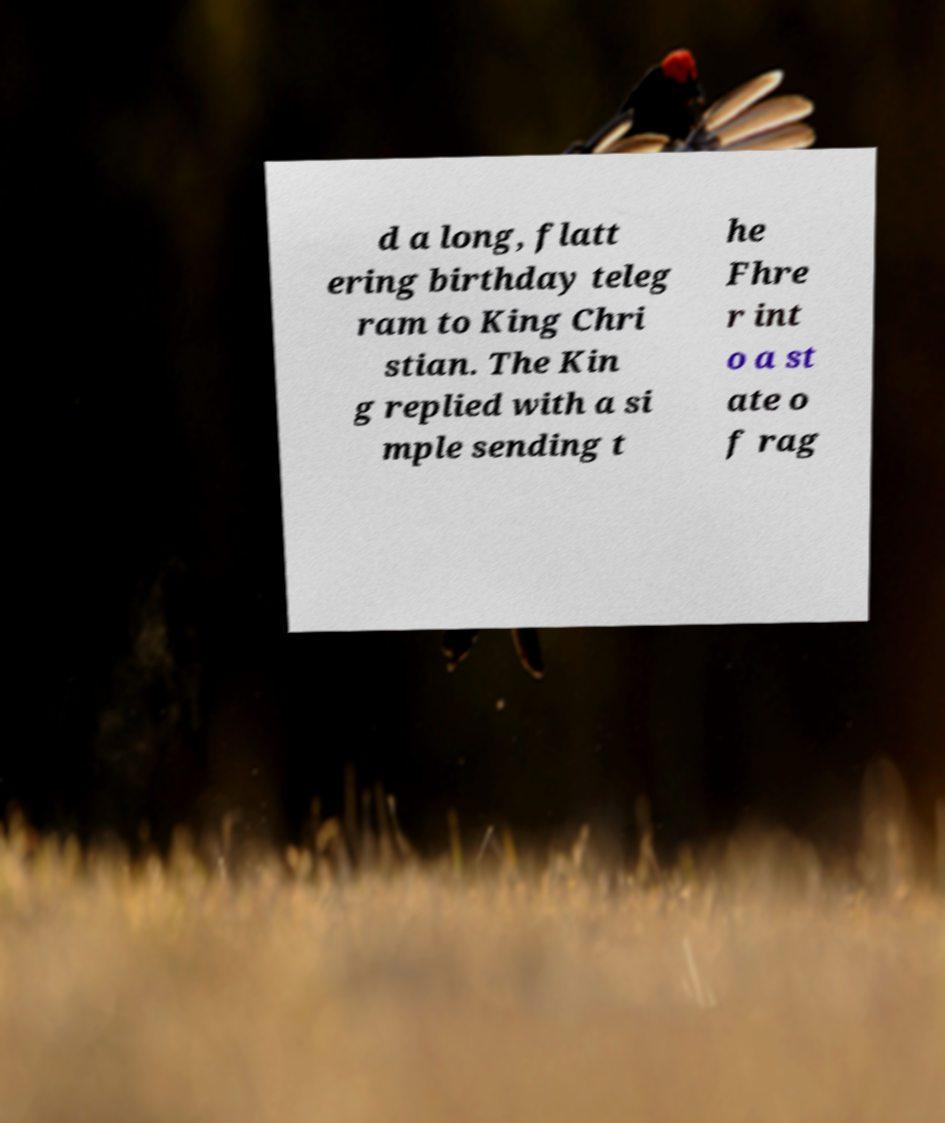Could you extract and type out the text from this image? d a long, flatt ering birthday teleg ram to King Chri stian. The Kin g replied with a si mple sending t he Fhre r int o a st ate o f rag 